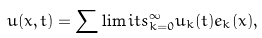<formula> <loc_0><loc_0><loc_500><loc_500>u ( x , t ) = \sum \lim i t s _ { k = 0 } ^ { \infty } u _ { k } ( t ) e _ { k } ( x ) ,</formula> 